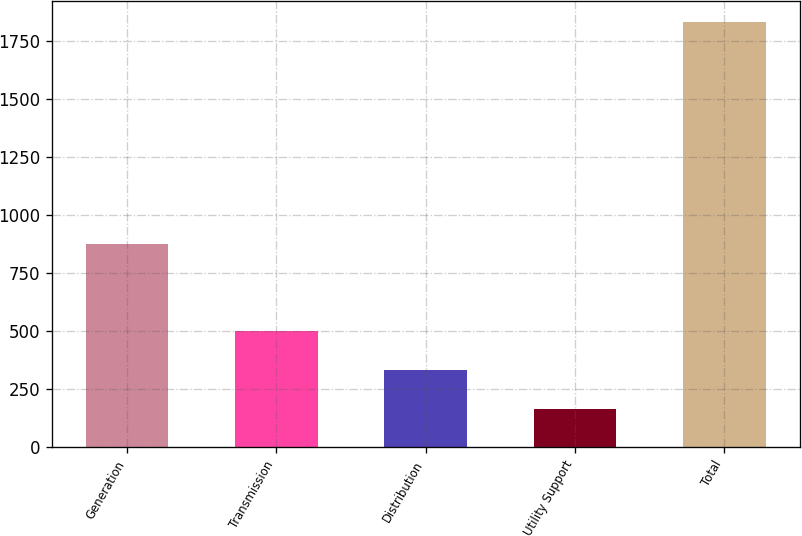Convert chart to OTSL. <chart><loc_0><loc_0><loc_500><loc_500><bar_chart><fcel>Generation<fcel>Transmission<fcel>Distribution<fcel>Utility Support<fcel>Total<nl><fcel>875<fcel>498<fcel>331.5<fcel>165<fcel>1830<nl></chart> 